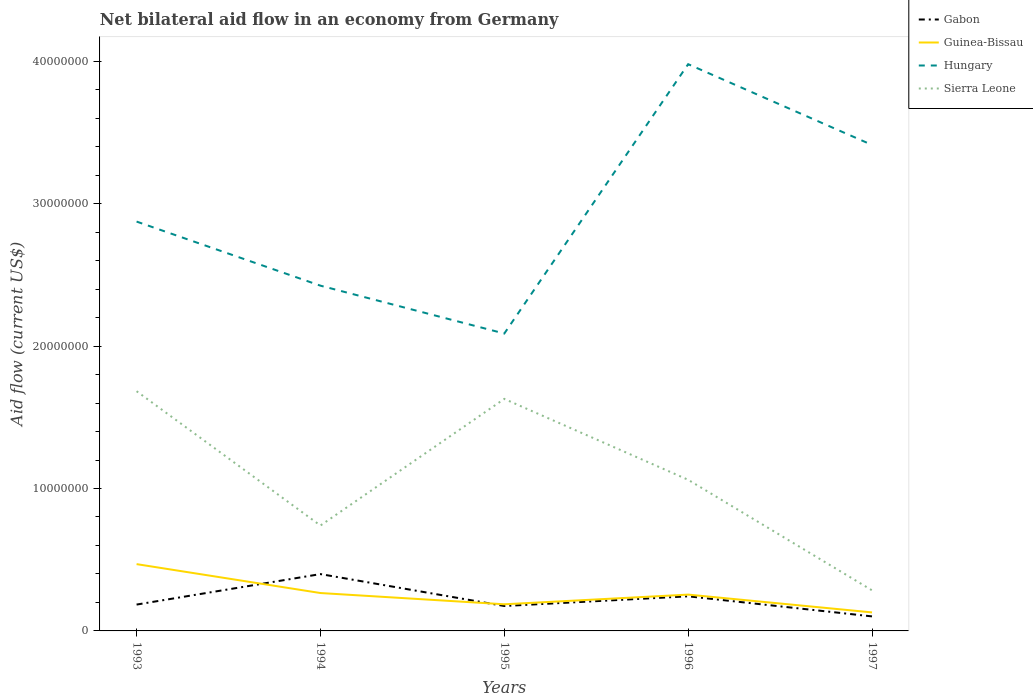Does the line corresponding to Sierra Leone intersect with the line corresponding to Hungary?
Provide a succinct answer. No. Is the number of lines equal to the number of legend labels?
Your response must be concise. Yes. Across all years, what is the maximum net bilateral aid flow in Guinea-Bissau?
Provide a succinct answer. 1.30e+06. What is the total net bilateral aid flow in Gabon in the graph?
Offer a very short reply. 2.24e+06. What is the difference between the highest and the second highest net bilateral aid flow in Gabon?
Give a very brief answer. 2.97e+06. What is the difference between the highest and the lowest net bilateral aid flow in Guinea-Bissau?
Keep it short and to the point. 2. How many lines are there?
Provide a succinct answer. 4. Are the values on the major ticks of Y-axis written in scientific E-notation?
Your answer should be compact. No. Does the graph contain any zero values?
Ensure brevity in your answer.  No. Where does the legend appear in the graph?
Your answer should be compact. Top right. How many legend labels are there?
Your response must be concise. 4. What is the title of the graph?
Offer a very short reply. Net bilateral aid flow in an economy from Germany. Does "Sao Tome and Principe" appear as one of the legend labels in the graph?
Offer a terse response. No. What is the label or title of the X-axis?
Offer a very short reply. Years. What is the label or title of the Y-axis?
Your answer should be very brief. Aid flow (current US$). What is the Aid flow (current US$) in Gabon in 1993?
Provide a succinct answer. 1.85e+06. What is the Aid flow (current US$) of Guinea-Bissau in 1993?
Keep it short and to the point. 4.69e+06. What is the Aid flow (current US$) of Hungary in 1993?
Provide a short and direct response. 2.87e+07. What is the Aid flow (current US$) of Sierra Leone in 1993?
Provide a succinct answer. 1.68e+07. What is the Aid flow (current US$) in Gabon in 1994?
Your response must be concise. 3.99e+06. What is the Aid flow (current US$) of Guinea-Bissau in 1994?
Ensure brevity in your answer.  2.66e+06. What is the Aid flow (current US$) in Hungary in 1994?
Your response must be concise. 2.42e+07. What is the Aid flow (current US$) of Sierra Leone in 1994?
Offer a terse response. 7.40e+06. What is the Aid flow (current US$) of Gabon in 1995?
Offer a terse response. 1.75e+06. What is the Aid flow (current US$) of Guinea-Bissau in 1995?
Make the answer very short. 1.87e+06. What is the Aid flow (current US$) in Hungary in 1995?
Provide a short and direct response. 2.09e+07. What is the Aid flow (current US$) of Sierra Leone in 1995?
Your answer should be compact. 1.63e+07. What is the Aid flow (current US$) of Gabon in 1996?
Provide a succinct answer. 2.43e+06. What is the Aid flow (current US$) of Guinea-Bissau in 1996?
Offer a terse response. 2.55e+06. What is the Aid flow (current US$) of Hungary in 1996?
Your answer should be very brief. 3.98e+07. What is the Aid flow (current US$) of Sierra Leone in 1996?
Provide a short and direct response. 1.06e+07. What is the Aid flow (current US$) of Gabon in 1997?
Keep it short and to the point. 1.02e+06. What is the Aid flow (current US$) of Guinea-Bissau in 1997?
Ensure brevity in your answer.  1.30e+06. What is the Aid flow (current US$) in Hungary in 1997?
Offer a very short reply. 3.41e+07. What is the Aid flow (current US$) of Sierra Leone in 1997?
Your answer should be compact. 2.85e+06. Across all years, what is the maximum Aid flow (current US$) in Gabon?
Offer a terse response. 3.99e+06. Across all years, what is the maximum Aid flow (current US$) in Guinea-Bissau?
Offer a very short reply. 4.69e+06. Across all years, what is the maximum Aid flow (current US$) of Hungary?
Give a very brief answer. 3.98e+07. Across all years, what is the maximum Aid flow (current US$) in Sierra Leone?
Offer a very short reply. 1.68e+07. Across all years, what is the minimum Aid flow (current US$) in Gabon?
Provide a short and direct response. 1.02e+06. Across all years, what is the minimum Aid flow (current US$) in Guinea-Bissau?
Offer a very short reply. 1.30e+06. Across all years, what is the minimum Aid flow (current US$) of Hungary?
Offer a terse response. 2.09e+07. Across all years, what is the minimum Aid flow (current US$) in Sierra Leone?
Offer a terse response. 2.85e+06. What is the total Aid flow (current US$) in Gabon in the graph?
Your answer should be compact. 1.10e+07. What is the total Aid flow (current US$) in Guinea-Bissau in the graph?
Your answer should be compact. 1.31e+07. What is the total Aid flow (current US$) of Hungary in the graph?
Ensure brevity in your answer.  1.48e+08. What is the total Aid flow (current US$) of Sierra Leone in the graph?
Provide a succinct answer. 5.40e+07. What is the difference between the Aid flow (current US$) of Gabon in 1993 and that in 1994?
Your response must be concise. -2.14e+06. What is the difference between the Aid flow (current US$) in Guinea-Bissau in 1993 and that in 1994?
Give a very brief answer. 2.03e+06. What is the difference between the Aid flow (current US$) in Hungary in 1993 and that in 1994?
Make the answer very short. 4.50e+06. What is the difference between the Aid flow (current US$) of Sierra Leone in 1993 and that in 1994?
Provide a short and direct response. 9.43e+06. What is the difference between the Aid flow (current US$) of Gabon in 1993 and that in 1995?
Make the answer very short. 1.00e+05. What is the difference between the Aid flow (current US$) of Guinea-Bissau in 1993 and that in 1995?
Your response must be concise. 2.82e+06. What is the difference between the Aid flow (current US$) in Hungary in 1993 and that in 1995?
Give a very brief answer. 7.86e+06. What is the difference between the Aid flow (current US$) in Sierra Leone in 1993 and that in 1995?
Your answer should be compact. 5.40e+05. What is the difference between the Aid flow (current US$) in Gabon in 1993 and that in 1996?
Provide a short and direct response. -5.80e+05. What is the difference between the Aid flow (current US$) of Guinea-Bissau in 1993 and that in 1996?
Your answer should be compact. 2.14e+06. What is the difference between the Aid flow (current US$) in Hungary in 1993 and that in 1996?
Offer a very short reply. -1.10e+07. What is the difference between the Aid flow (current US$) of Sierra Leone in 1993 and that in 1996?
Make the answer very short. 6.22e+06. What is the difference between the Aid flow (current US$) in Gabon in 1993 and that in 1997?
Keep it short and to the point. 8.30e+05. What is the difference between the Aid flow (current US$) of Guinea-Bissau in 1993 and that in 1997?
Offer a very short reply. 3.39e+06. What is the difference between the Aid flow (current US$) of Hungary in 1993 and that in 1997?
Provide a short and direct response. -5.38e+06. What is the difference between the Aid flow (current US$) in Sierra Leone in 1993 and that in 1997?
Make the answer very short. 1.40e+07. What is the difference between the Aid flow (current US$) of Gabon in 1994 and that in 1995?
Your answer should be compact. 2.24e+06. What is the difference between the Aid flow (current US$) of Guinea-Bissau in 1994 and that in 1995?
Ensure brevity in your answer.  7.90e+05. What is the difference between the Aid flow (current US$) of Hungary in 1994 and that in 1995?
Provide a short and direct response. 3.36e+06. What is the difference between the Aid flow (current US$) of Sierra Leone in 1994 and that in 1995?
Keep it short and to the point. -8.89e+06. What is the difference between the Aid flow (current US$) in Gabon in 1994 and that in 1996?
Your answer should be very brief. 1.56e+06. What is the difference between the Aid flow (current US$) in Guinea-Bissau in 1994 and that in 1996?
Make the answer very short. 1.10e+05. What is the difference between the Aid flow (current US$) of Hungary in 1994 and that in 1996?
Give a very brief answer. -1.56e+07. What is the difference between the Aid flow (current US$) in Sierra Leone in 1994 and that in 1996?
Your answer should be compact. -3.21e+06. What is the difference between the Aid flow (current US$) of Gabon in 1994 and that in 1997?
Provide a succinct answer. 2.97e+06. What is the difference between the Aid flow (current US$) of Guinea-Bissau in 1994 and that in 1997?
Provide a short and direct response. 1.36e+06. What is the difference between the Aid flow (current US$) in Hungary in 1994 and that in 1997?
Offer a terse response. -9.88e+06. What is the difference between the Aid flow (current US$) in Sierra Leone in 1994 and that in 1997?
Offer a terse response. 4.55e+06. What is the difference between the Aid flow (current US$) in Gabon in 1995 and that in 1996?
Your response must be concise. -6.80e+05. What is the difference between the Aid flow (current US$) in Guinea-Bissau in 1995 and that in 1996?
Give a very brief answer. -6.80e+05. What is the difference between the Aid flow (current US$) of Hungary in 1995 and that in 1996?
Offer a very short reply. -1.89e+07. What is the difference between the Aid flow (current US$) of Sierra Leone in 1995 and that in 1996?
Give a very brief answer. 5.68e+06. What is the difference between the Aid flow (current US$) in Gabon in 1995 and that in 1997?
Keep it short and to the point. 7.30e+05. What is the difference between the Aid flow (current US$) in Guinea-Bissau in 1995 and that in 1997?
Give a very brief answer. 5.70e+05. What is the difference between the Aid flow (current US$) in Hungary in 1995 and that in 1997?
Your answer should be compact. -1.32e+07. What is the difference between the Aid flow (current US$) of Sierra Leone in 1995 and that in 1997?
Ensure brevity in your answer.  1.34e+07. What is the difference between the Aid flow (current US$) in Gabon in 1996 and that in 1997?
Provide a succinct answer. 1.41e+06. What is the difference between the Aid flow (current US$) in Guinea-Bissau in 1996 and that in 1997?
Offer a terse response. 1.25e+06. What is the difference between the Aid flow (current US$) of Hungary in 1996 and that in 1997?
Keep it short and to the point. 5.67e+06. What is the difference between the Aid flow (current US$) in Sierra Leone in 1996 and that in 1997?
Your response must be concise. 7.76e+06. What is the difference between the Aid flow (current US$) of Gabon in 1993 and the Aid flow (current US$) of Guinea-Bissau in 1994?
Provide a succinct answer. -8.10e+05. What is the difference between the Aid flow (current US$) in Gabon in 1993 and the Aid flow (current US$) in Hungary in 1994?
Your response must be concise. -2.24e+07. What is the difference between the Aid flow (current US$) of Gabon in 1993 and the Aid flow (current US$) of Sierra Leone in 1994?
Offer a terse response. -5.55e+06. What is the difference between the Aid flow (current US$) in Guinea-Bissau in 1993 and the Aid flow (current US$) in Hungary in 1994?
Ensure brevity in your answer.  -1.96e+07. What is the difference between the Aid flow (current US$) of Guinea-Bissau in 1993 and the Aid flow (current US$) of Sierra Leone in 1994?
Ensure brevity in your answer.  -2.71e+06. What is the difference between the Aid flow (current US$) of Hungary in 1993 and the Aid flow (current US$) of Sierra Leone in 1994?
Keep it short and to the point. 2.13e+07. What is the difference between the Aid flow (current US$) in Gabon in 1993 and the Aid flow (current US$) in Hungary in 1995?
Ensure brevity in your answer.  -1.90e+07. What is the difference between the Aid flow (current US$) of Gabon in 1993 and the Aid flow (current US$) of Sierra Leone in 1995?
Make the answer very short. -1.44e+07. What is the difference between the Aid flow (current US$) of Guinea-Bissau in 1993 and the Aid flow (current US$) of Hungary in 1995?
Give a very brief answer. -1.62e+07. What is the difference between the Aid flow (current US$) of Guinea-Bissau in 1993 and the Aid flow (current US$) of Sierra Leone in 1995?
Your answer should be compact. -1.16e+07. What is the difference between the Aid flow (current US$) in Hungary in 1993 and the Aid flow (current US$) in Sierra Leone in 1995?
Offer a very short reply. 1.24e+07. What is the difference between the Aid flow (current US$) in Gabon in 1993 and the Aid flow (current US$) in Guinea-Bissau in 1996?
Your answer should be very brief. -7.00e+05. What is the difference between the Aid flow (current US$) in Gabon in 1993 and the Aid flow (current US$) in Hungary in 1996?
Keep it short and to the point. -3.79e+07. What is the difference between the Aid flow (current US$) of Gabon in 1993 and the Aid flow (current US$) of Sierra Leone in 1996?
Provide a short and direct response. -8.76e+06. What is the difference between the Aid flow (current US$) in Guinea-Bissau in 1993 and the Aid flow (current US$) in Hungary in 1996?
Provide a short and direct response. -3.51e+07. What is the difference between the Aid flow (current US$) in Guinea-Bissau in 1993 and the Aid flow (current US$) in Sierra Leone in 1996?
Offer a very short reply. -5.92e+06. What is the difference between the Aid flow (current US$) of Hungary in 1993 and the Aid flow (current US$) of Sierra Leone in 1996?
Give a very brief answer. 1.81e+07. What is the difference between the Aid flow (current US$) of Gabon in 1993 and the Aid flow (current US$) of Guinea-Bissau in 1997?
Offer a terse response. 5.50e+05. What is the difference between the Aid flow (current US$) in Gabon in 1993 and the Aid flow (current US$) in Hungary in 1997?
Provide a short and direct response. -3.23e+07. What is the difference between the Aid flow (current US$) of Guinea-Bissau in 1993 and the Aid flow (current US$) of Hungary in 1997?
Your answer should be very brief. -2.94e+07. What is the difference between the Aid flow (current US$) in Guinea-Bissau in 1993 and the Aid flow (current US$) in Sierra Leone in 1997?
Offer a very short reply. 1.84e+06. What is the difference between the Aid flow (current US$) in Hungary in 1993 and the Aid flow (current US$) in Sierra Leone in 1997?
Provide a short and direct response. 2.59e+07. What is the difference between the Aid flow (current US$) of Gabon in 1994 and the Aid flow (current US$) of Guinea-Bissau in 1995?
Offer a terse response. 2.12e+06. What is the difference between the Aid flow (current US$) in Gabon in 1994 and the Aid flow (current US$) in Hungary in 1995?
Ensure brevity in your answer.  -1.69e+07. What is the difference between the Aid flow (current US$) in Gabon in 1994 and the Aid flow (current US$) in Sierra Leone in 1995?
Make the answer very short. -1.23e+07. What is the difference between the Aid flow (current US$) in Guinea-Bissau in 1994 and the Aid flow (current US$) in Hungary in 1995?
Keep it short and to the point. -1.82e+07. What is the difference between the Aid flow (current US$) in Guinea-Bissau in 1994 and the Aid flow (current US$) in Sierra Leone in 1995?
Give a very brief answer. -1.36e+07. What is the difference between the Aid flow (current US$) in Hungary in 1994 and the Aid flow (current US$) in Sierra Leone in 1995?
Make the answer very short. 7.95e+06. What is the difference between the Aid flow (current US$) of Gabon in 1994 and the Aid flow (current US$) of Guinea-Bissau in 1996?
Offer a very short reply. 1.44e+06. What is the difference between the Aid flow (current US$) of Gabon in 1994 and the Aid flow (current US$) of Hungary in 1996?
Offer a terse response. -3.58e+07. What is the difference between the Aid flow (current US$) in Gabon in 1994 and the Aid flow (current US$) in Sierra Leone in 1996?
Make the answer very short. -6.62e+06. What is the difference between the Aid flow (current US$) in Guinea-Bissau in 1994 and the Aid flow (current US$) in Hungary in 1996?
Make the answer very short. -3.71e+07. What is the difference between the Aid flow (current US$) in Guinea-Bissau in 1994 and the Aid flow (current US$) in Sierra Leone in 1996?
Ensure brevity in your answer.  -7.95e+06. What is the difference between the Aid flow (current US$) of Hungary in 1994 and the Aid flow (current US$) of Sierra Leone in 1996?
Offer a very short reply. 1.36e+07. What is the difference between the Aid flow (current US$) of Gabon in 1994 and the Aid flow (current US$) of Guinea-Bissau in 1997?
Give a very brief answer. 2.69e+06. What is the difference between the Aid flow (current US$) in Gabon in 1994 and the Aid flow (current US$) in Hungary in 1997?
Provide a succinct answer. -3.01e+07. What is the difference between the Aid flow (current US$) of Gabon in 1994 and the Aid flow (current US$) of Sierra Leone in 1997?
Keep it short and to the point. 1.14e+06. What is the difference between the Aid flow (current US$) of Guinea-Bissau in 1994 and the Aid flow (current US$) of Hungary in 1997?
Your answer should be compact. -3.15e+07. What is the difference between the Aid flow (current US$) of Guinea-Bissau in 1994 and the Aid flow (current US$) of Sierra Leone in 1997?
Keep it short and to the point. -1.90e+05. What is the difference between the Aid flow (current US$) in Hungary in 1994 and the Aid flow (current US$) in Sierra Leone in 1997?
Give a very brief answer. 2.14e+07. What is the difference between the Aid flow (current US$) in Gabon in 1995 and the Aid flow (current US$) in Guinea-Bissau in 1996?
Keep it short and to the point. -8.00e+05. What is the difference between the Aid flow (current US$) of Gabon in 1995 and the Aid flow (current US$) of Hungary in 1996?
Give a very brief answer. -3.80e+07. What is the difference between the Aid flow (current US$) of Gabon in 1995 and the Aid flow (current US$) of Sierra Leone in 1996?
Offer a terse response. -8.86e+06. What is the difference between the Aid flow (current US$) in Guinea-Bissau in 1995 and the Aid flow (current US$) in Hungary in 1996?
Offer a very short reply. -3.79e+07. What is the difference between the Aid flow (current US$) in Guinea-Bissau in 1995 and the Aid flow (current US$) in Sierra Leone in 1996?
Provide a succinct answer. -8.74e+06. What is the difference between the Aid flow (current US$) of Hungary in 1995 and the Aid flow (current US$) of Sierra Leone in 1996?
Offer a very short reply. 1.03e+07. What is the difference between the Aid flow (current US$) of Gabon in 1995 and the Aid flow (current US$) of Guinea-Bissau in 1997?
Ensure brevity in your answer.  4.50e+05. What is the difference between the Aid flow (current US$) in Gabon in 1995 and the Aid flow (current US$) in Hungary in 1997?
Ensure brevity in your answer.  -3.24e+07. What is the difference between the Aid flow (current US$) in Gabon in 1995 and the Aid flow (current US$) in Sierra Leone in 1997?
Offer a very short reply. -1.10e+06. What is the difference between the Aid flow (current US$) of Guinea-Bissau in 1995 and the Aid flow (current US$) of Hungary in 1997?
Keep it short and to the point. -3.22e+07. What is the difference between the Aid flow (current US$) in Guinea-Bissau in 1995 and the Aid flow (current US$) in Sierra Leone in 1997?
Make the answer very short. -9.80e+05. What is the difference between the Aid flow (current US$) of Hungary in 1995 and the Aid flow (current US$) of Sierra Leone in 1997?
Provide a succinct answer. 1.80e+07. What is the difference between the Aid flow (current US$) of Gabon in 1996 and the Aid flow (current US$) of Guinea-Bissau in 1997?
Your response must be concise. 1.13e+06. What is the difference between the Aid flow (current US$) of Gabon in 1996 and the Aid flow (current US$) of Hungary in 1997?
Give a very brief answer. -3.17e+07. What is the difference between the Aid flow (current US$) of Gabon in 1996 and the Aid flow (current US$) of Sierra Leone in 1997?
Offer a terse response. -4.20e+05. What is the difference between the Aid flow (current US$) of Guinea-Bissau in 1996 and the Aid flow (current US$) of Hungary in 1997?
Your answer should be very brief. -3.16e+07. What is the difference between the Aid flow (current US$) in Hungary in 1996 and the Aid flow (current US$) in Sierra Leone in 1997?
Your answer should be compact. 3.69e+07. What is the average Aid flow (current US$) of Gabon per year?
Your answer should be compact. 2.21e+06. What is the average Aid flow (current US$) of Guinea-Bissau per year?
Offer a very short reply. 2.61e+06. What is the average Aid flow (current US$) in Hungary per year?
Your answer should be compact. 2.96e+07. What is the average Aid flow (current US$) in Sierra Leone per year?
Ensure brevity in your answer.  1.08e+07. In the year 1993, what is the difference between the Aid flow (current US$) in Gabon and Aid flow (current US$) in Guinea-Bissau?
Offer a terse response. -2.84e+06. In the year 1993, what is the difference between the Aid flow (current US$) in Gabon and Aid flow (current US$) in Hungary?
Your answer should be compact. -2.69e+07. In the year 1993, what is the difference between the Aid flow (current US$) of Gabon and Aid flow (current US$) of Sierra Leone?
Your answer should be very brief. -1.50e+07. In the year 1993, what is the difference between the Aid flow (current US$) of Guinea-Bissau and Aid flow (current US$) of Hungary?
Provide a succinct answer. -2.40e+07. In the year 1993, what is the difference between the Aid flow (current US$) in Guinea-Bissau and Aid flow (current US$) in Sierra Leone?
Provide a short and direct response. -1.21e+07. In the year 1993, what is the difference between the Aid flow (current US$) in Hungary and Aid flow (current US$) in Sierra Leone?
Offer a very short reply. 1.19e+07. In the year 1994, what is the difference between the Aid flow (current US$) in Gabon and Aid flow (current US$) in Guinea-Bissau?
Give a very brief answer. 1.33e+06. In the year 1994, what is the difference between the Aid flow (current US$) in Gabon and Aid flow (current US$) in Hungary?
Offer a terse response. -2.02e+07. In the year 1994, what is the difference between the Aid flow (current US$) in Gabon and Aid flow (current US$) in Sierra Leone?
Provide a short and direct response. -3.41e+06. In the year 1994, what is the difference between the Aid flow (current US$) in Guinea-Bissau and Aid flow (current US$) in Hungary?
Offer a very short reply. -2.16e+07. In the year 1994, what is the difference between the Aid flow (current US$) in Guinea-Bissau and Aid flow (current US$) in Sierra Leone?
Keep it short and to the point. -4.74e+06. In the year 1994, what is the difference between the Aid flow (current US$) of Hungary and Aid flow (current US$) of Sierra Leone?
Provide a succinct answer. 1.68e+07. In the year 1995, what is the difference between the Aid flow (current US$) in Gabon and Aid flow (current US$) in Hungary?
Offer a very short reply. -1.91e+07. In the year 1995, what is the difference between the Aid flow (current US$) of Gabon and Aid flow (current US$) of Sierra Leone?
Provide a short and direct response. -1.45e+07. In the year 1995, what is the difference between the Aid flow (current US$) of Guinea-Bissau and Aid flow (current US$) of Hungary?
Provide a succinct answer. -1.90e+07. In the year 1995, what is the difference between the Aid flow (current US$) of Guinea-Bissau and Aid flow (current US$) of Sierra Leone?
Offer a terse response. -1.44e+07. In the year 1995, what is the difference between the Aid flow (current US$) in Hungary and Aid flow (current US$) in Sierra Leone?
Keep it short and to the point. 4.59e+06. In the year 1996, what is the difference between the Aid flow (current US$) in Gabon and Aid flow (current US$) in Guinea-Bissau?
Your answer should be very brief. -1.20e+05. In the year 1996, what is the difference between the Aid flow (current US$) in Gabon and Aid flow (current US$) in Hungary?
Give a very brief answer. -3.74e+07. In the year 1996, what is the difference between the Aid flow (current US$) of Gabon and Aid flow (current US$) of Sierra Leone?
Keep it short and to the point. -8.18e+06. In the year 1996, what is the difference between the Aid flow (current US$) of Guinea-Bissau and Aid flow (current US$) of Hungary?
Make the answer very short. -3.72e+07. In the year 1996, what is the difference between the Aid flow (current US$) in Guinea-Bissau and Aid flow (current US$) in Sierra Leone?
Make the answer very short. -8.06e+06. In the year 1996, what is the difference between the Aid flow (current US$) in Hungary and Aid flow (current US$) in Sierra Leone?
Offer a very short reply. 2.92e+07. In the year 1997, what is the difference between the Aid flow (current US$) in Gabon and Aid flow (current US$) in Guinea-Bissau?
Provide a short and direct response. -2.80e+05. In the year 1997, what is the difference between the Aid flow (current US$) in Gabon and Aid flow (current US$) in Hungary?
Ensure brevity in your answer.  -3.31e+07. In the year 1997, what is the difference between the Aid flow (current US$) in Gabon and Aid flow (current US$) in Sierra Leone?
Keep it short and to the point. -1.83e+06. In the year 1997, what is the difference between the Aid flow (current US$) in Guinea-Bissau and Aid flow (current US$) in Hungary?
Your response must be concise. -3.28e+07. In the year 1997, what is the difference between the Aid flow (current US$) of Guinea-Bissau and Aid flow (current US$) of Sierra Leone?
Make the answer very short. -1.55e+06. In the year 1997, what is the difference between the Aid flow (current US$) of Hungary and Aid flow (current US$) of Sierra Leone?
Your response must be concise. 3.13e+07. What is the ratio of the Aid flow (current US$) of Gabon in 1993 to that in 1994?
Your answer should be compact. 0.46. What is the ratio of the Aid flow (current US$) of Guinea-Bissau in 1993 to that in 1994?
Ensure brevity in your answer.  1.76. What is the ratio of the Aid flow (current US$) of Hungary in 1993 to that in 1994?
Offer a terse response. 1.19. What is the ratio of the Aid flow (current US$) in Sierra Leone in 1993 to that in 1994?
Keep it short and to the point. 2.27. What is the ratio of the Aid flow (current US$) in Gabon in 1993 to that in 1995?
Provide a succinct answer. 1.06. What is the ratio of the Aid flow (current US$) in Guinea-Bissau in 1993 to that in 1995?
Offer a very short reply. 2.51. What is the ratio of the Aid flow (current US$) in Hungary in 1993 to that in 1995?
Give a very brief answer. 1.38. What is the ratio of the Aid flow (current US$) in Sierra Leone in 1993 to that in 1995?
Provide a short and direct response. 1.03. What is the ratio of the Aid flow (current US$) in Gabon in 1993 to that in 1996?
Offer a terse response. 0.76. What is the ratio of the Aid flow (current US$) in Guinea-Bissau in 1993 to that in 1996?
Keep it short and to the point. 1.84. What is the ratio of the Aid flow (current US$) in Hungary in 1993 to that in 1996?
Give a very brief answer. 0.72. What is the ratio of the Aid flow (current US$) of Sierra Leone in 1993 to that in 1996?
Your answer should be very brief. 1.59. What is the ratio of the Aid flow (current US$) in Gabon in 1993 to that in 1997?
Give a very brief answer. 1.81. What is the ratio of the Aid flow (current US$) of Guinea-Bissau in 1993 to that in 1997?
Offer a terse response. 3.61. What is the ratio of the Aid flow (current US$) of Hungary in 1993 to that in 1997?
Provide a short and direct response. 0.84. What is the ratio of the Aid flow (current US$) in Sierra Leone in 1993 to that in 1997?
Your answer should be very brief. 5.91. What is the ratio of the Aid flow (current US$) of Gabon in 1994 to that in 1995?
Your response must be concise. 2.28. What is the ratio of the Aid flow (current US$) in Guinea-Bissau in 1994 to that in 1995?
Give a very brief answer. 1.42. What is the ratio of the Aid flow (current US$) in Hungary in 1994 to that in 1995?
Make the answer very short. 1.16. What is the ratio of the Aid flow (current US$) of Sierra Leone in 1994 to that in 1995?
Provide a succinct answer. 0.45. What is the ratio of the Aid flow (current US$) of Gabon in 1994 to that in 1996?
Offer a very short reply. 1.64. What is the ratio of the Aid flow (current US$) in Guinea-Bissau in 1994 to that in 1996?
Offer a terse response. 1.04. What is the ratio of the Aid flow (current US$) in Hungary in 1994 to that in 1996?
Keep it short and to the point. 0.61. What is the ratio of the Aid flow (current US$) of Sierra Leone in 1994 to that in 1996?
Provide a short and direct response. 0.7. What is the ratio of the Aid flow (current US$) in Gabon in 1994 to that in 1997?
Keep it short and to the point. 3.91. What is the ratio of the Aid flow (current US$) in Guinea-Bissau in 1994 to that in 1997?
Offer a terse response. 2.05. What is the ratio of the Aid flow (current US$) of Hungary in 1994 to that in 1997?
Give a very brief answer. 0.71. What is the ratio of the Aid flow (current US$) of Sierra Leone in 1994 to that in 1997?
Provide a succinct answer. 2.6. What is the ratio of the Aid flow (current US$) in Gabon in 1995 to that in 1996?
Keep it short and to the point. 0.72. What is the ratio of the Aid flow (current US$) in Guinea-Bissau in 1995 to that in 1996?
Your answer should be compact. 0.73. What is the ratio of the Aid flow (current US$) in Hungary in 1995 to that in 1996?
Your response must be concise. 0.52. What is the ratio of the Aid flow (current US$) in Sierra Leone in 1995 to that in 1996?
Offer a terse response. 1.54. What is the ratio of the Aid flow (current US$) of Gabon in 1995 to that in 1997?
Keep it short and to the point. 1.72. What is the ratio of the Aid flow (current US$) in Guinea-Bissau in 1995 to that in 1997?
Offer a very short reply. 1.44. What is the ratio of the Aid flow (current US$) in Hungary in 1995 to that in 1997?
Make the answer very short. 0.61. What is the ratio of the Aid flow (current US$) in Sierra Leone in 1995 to that in 1997?
Keep it short and to the point. 5.72. What is the ratio of the Aid flow (current US$) in Gabon in 1996 to that in 1997?
Give a very brief answer. 2.38. What is the ratio of the Aid flow (current US$) of Guinea-Bissau in 1996 to that in 1997?
Provide a short and direct response. 1.96. What is the ratio of the Aid flow (current US$) in Hungary in 1996 to that in 1997?
Offer a terse response. 1.17. What is the ratio of the Aid flow (current US$) of Sierra Leone in 1996 to that in 1997?
Offer a very short reply. 3.72. What is the difference between the highest and the second highest Aid flow (current US$) of Gabon?
Make the answer very short. 1.56e+06. What is the difference between the highest and the second highest Aid flow (current US$) of Guinea-Bissau?
Ensure brevity in your answer.  2.03e+06. What is the difference between the highest and the second highest Aid flow (current US$) in Hungary?
Provide a short and direct response. 5.67e+06. What is the difference between the highest and the second highest Aid flow (current US$) of Sierra Leone?
Keep it short and to the point. 5.40e+05. What is the difference between the highest and the lowest Aid flow (current US$) in Gabon?
Keep it short and to the point. 2.97e+06. What is the difference between the highest and the lowest Aid flow (current US$) of Guinea-Bissau?
Your response must be concise. 3.39e+06. What is the difference between the highest and the lowest Aid flow (current US$) of Hungary?
Keep it short and to the point. 1.89e+07. What is the difference between the highest and the lowest Aid flow (current US$) of Sierra Leone?
Keep it short and to the point. 1.40e+07. 